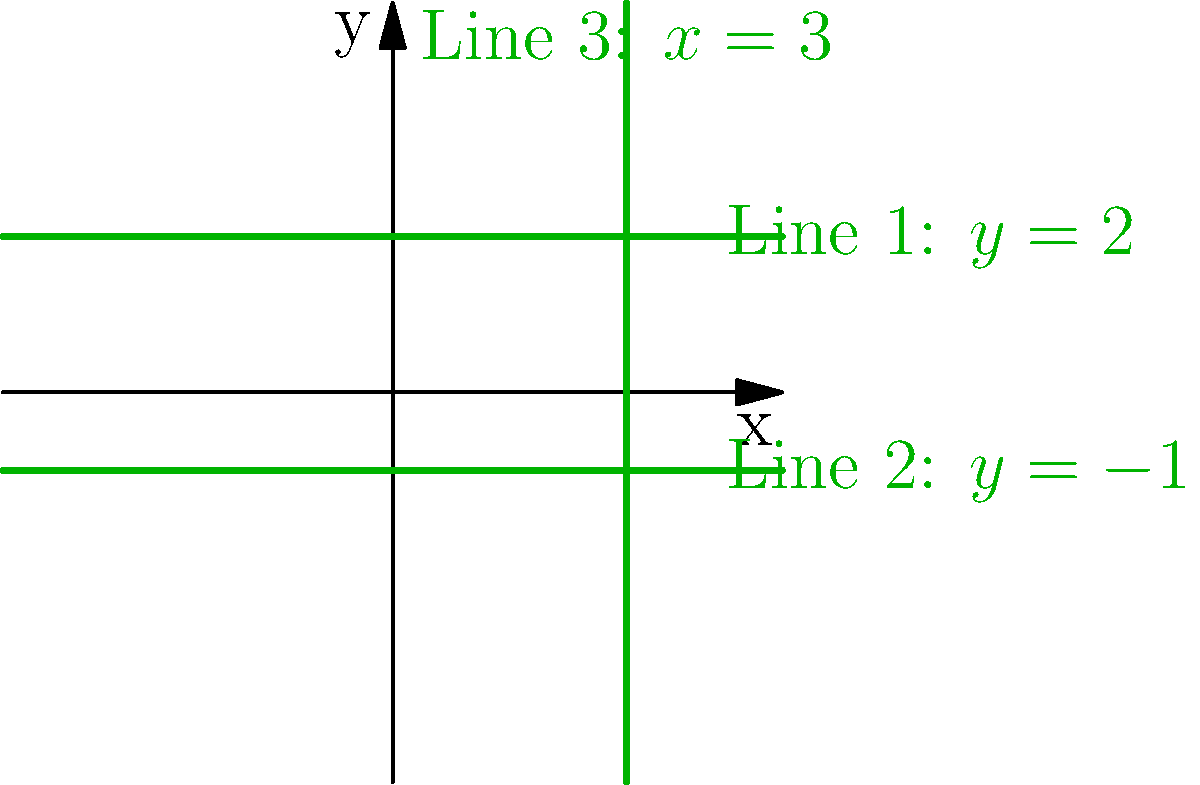In designing efficient robot movement patterns for the robotics club, you need to identify parallel and perpendicular lines. Given the three lines shown in the coordinate plane above, which pair of lines are parallel, and which line is perpendicular to both of them? Let's approach this step-by-step:

1) First, recall that parallel lines have the same slope, while perpendicular lines have slopes that are negative reciprocals of each other.

2) Let's identify the equations of the lines:
   Line 1: $y = 2$
   Line 2: $y = -1$
   Line 3: $x = 3$

3) For Line 1 and Line 2:
   - Both are horizontal lines with equations in the form $y = k$, where $k$ is a constant.
   - Horizontal lines have a slope of 0.
   - Since they have the same slope, Lines 1 and 2 are parallel.

4) For Line 3:
   - This is a vertical line with equation $x = 3$.
   - Vertical lines have an undefined slope.

5) Perpendicular lines:
   - Horizontal lines (slope = 0) and vertical lines (undefined slope) are always perpendicular to each other.
   - Therefore, Line 3 is perpendicular to both Line 1 and Line 2.

Thus, Lines 1 and 2 are parallel to each other, and Line 3 is perpendicular to both of them.
Answer: Lines 1 and 2 are parallel; Line 3 is perpendicular to both. 